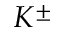<formula> <loc_0><loc_0><loc_500><loc_500>K ^ { \pm }</formula> 